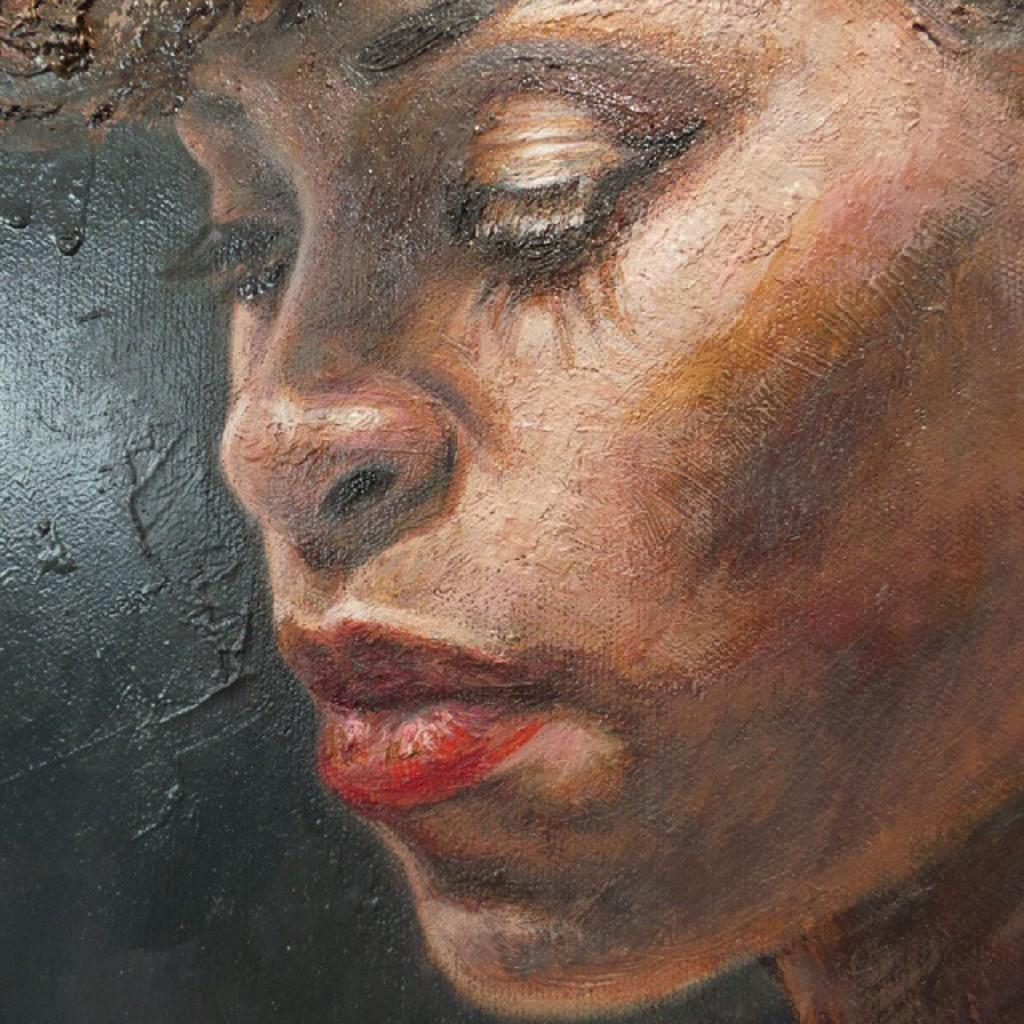What is depicted in the painting in the image? There is a painting of a person's face in the image. What color is the background of the painting? The background of the painting is black. Can you tell me how many times the son has touched the moon in the image? There is no son or moon present in the image; it only features a painting of a person's face with a black background. 